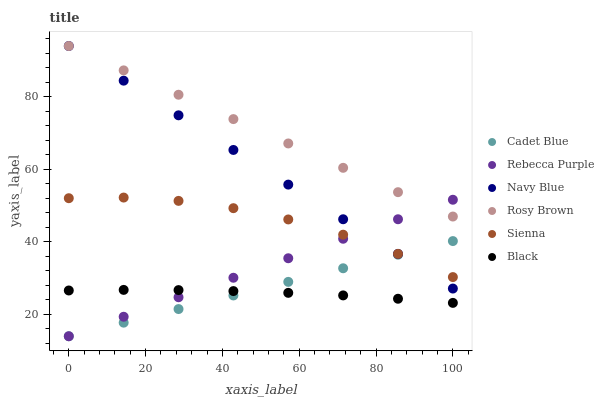Does Black have the minimum area under the curve?
Answer yes or no. Yes. Does Rosy Brown have the maximum area under the curve?
Answer yes or no. Yes. Does Navy Blue have the minimum area under the curve?
Answer yes or no. No. Does Navy Blue have the maximum area under the curve?
Answer yes or no. No. Is Rebecca Purple the smoothest?
Answer yes or no. Yes. Is Sienna the roughest?
Answer yes or no. Yes. Is Navy Blue the smoothest?
Answer yes or no. No. Is Navy Blue the roughest?
Answer yes or no. No. Does Cadet Blue have the lowest value?
Answer yes or no. Yes. Does Navy Blue have the lowest value?
Answer yes or no. No. Does Rosy Brown have the highest value?
Answer yes or no. Yes. Does Sienna have the highest value?
Answer yes or no. No. Is Cadet Blue less than Rosy Brown?
Answer yes or no. Yes. Is Navy Blue greater than Black?
Answer yes or no. Yes. Does Rosy Brown intersect Navy Blue?
Answer yes or no. Yes. Is Rosy Brown less than Navy Blue?
Answer yes or no. No. Is Rosy Brown greater than Navy Blue?
Answer yes or no. No. Does Cadet Blue intersect Rosy Brown?
Answer yes or no. No. 